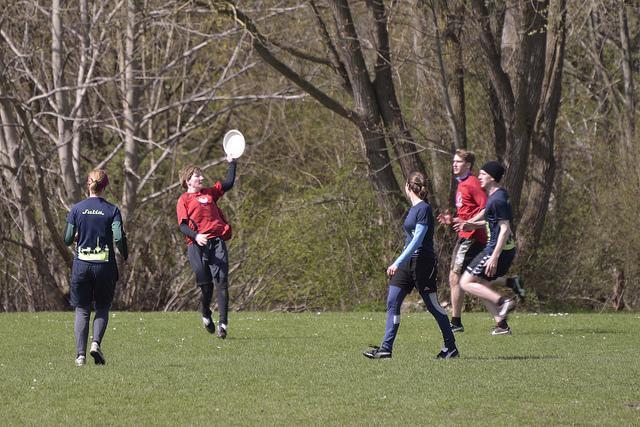How many people are there?
Give a very brief answer. 5. How many people are on the blue team?
Give a very brief answer. 3. How many people are wearing red?
Give a very brief answer. 2. 